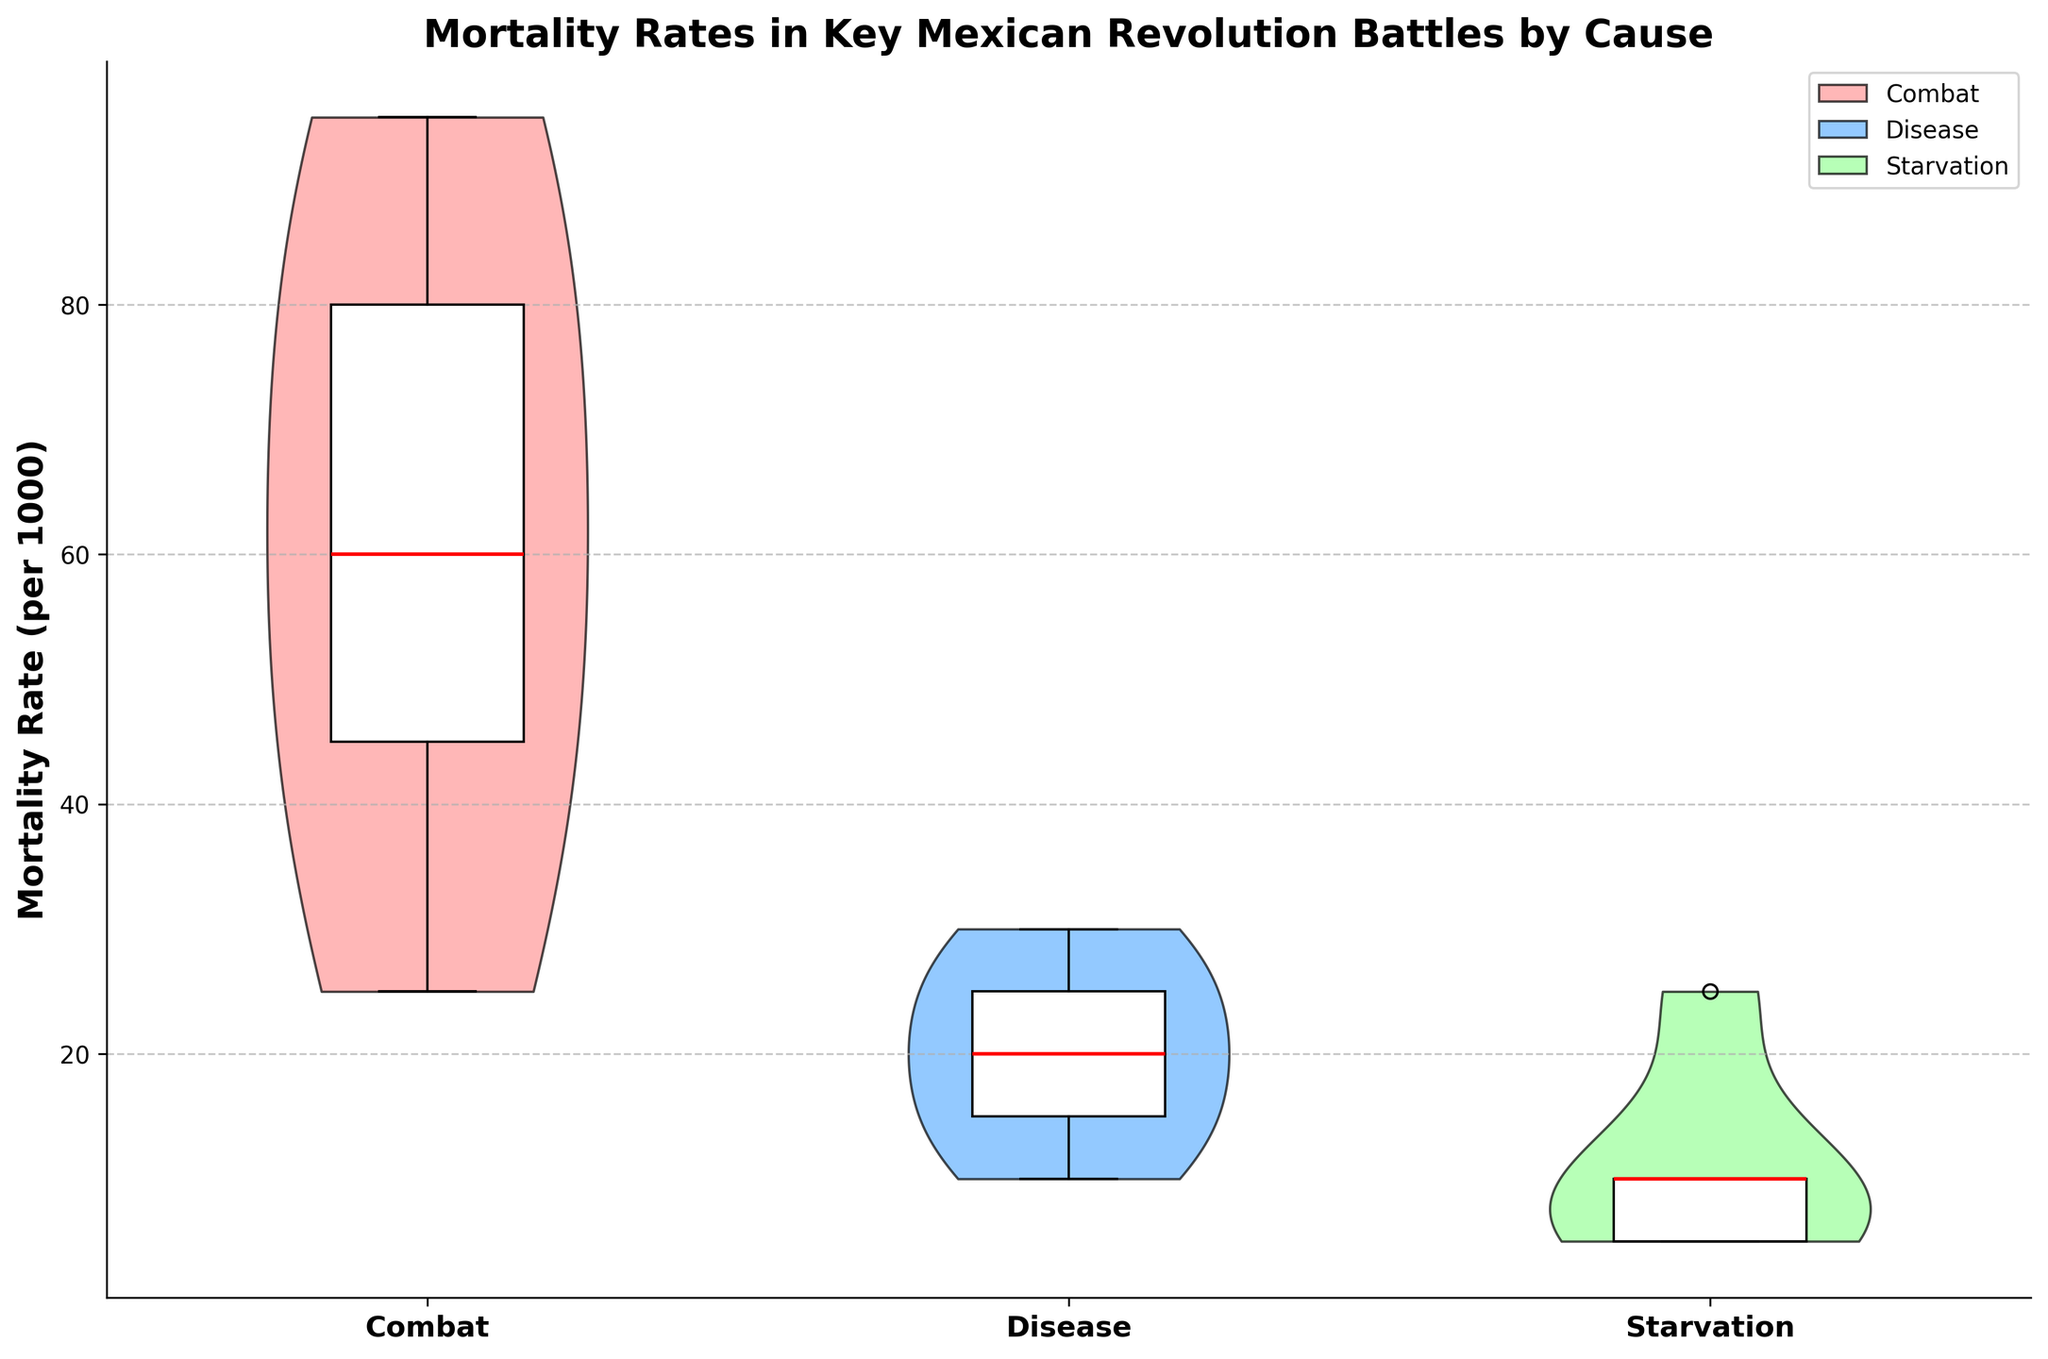What is the title of the figure? The title is located at the top of the figure and describes what the figure represents.
Answer: Mortality Rates in Key Mexican Revolution Battles by Cause What does the y-axis label indicate? The y-axis label, located along the vertical axis, describes the variable measured there.
Answer: Mortality Rate (per 1000) What causes are represented on the x-axis, and how are they visually distinguished? The x-axis indicates different causes of mortality, each represented with different colors in the violin plots and box plots. The colors included are red, blue, and green for combat, disease, and starvation respectively.
Answer: Combat, Disease, Starvation Which cause of mortality shows the highest median value in the box plot? The median value is represented by the red line within the box plot for each category. The highest median is observed in the category where the red line is highest.
Answer: Combat How does the distribution of mortality rates due to combat compare to disease? The violin plot for combat shows a wider spread of data points compared to disease, indicating greater variability. Additionally, the box plot for combat has a higher median value than disease.
Answer: Combat shows greater variability and a higher median than disease What is the interquartile range (IQR) for mortality rates due to starvation? The interquartile range (IQR) can be determined from the box plot for starvation. It's the range between the first quartile (lower edge of the box) and the third quartile (upper edge of the box). From the box plot, observe these values and compute the difference.
Answer: 10 Among the causes of mortality, which one has the least variability in mortality rates as shown in the violin plot? Variability in the violin plot can be assessed by looking at the 'spread' of the plot. Narrower spreads indicate less variability.
Answer: Starvation What is the total number of data points represented for mortality rates due to disease? Each point within the violin plot or box plot for disease will typically correspond to an individual data point. Count all such data points.
Answer: 5 Compare the median mortality rates of combat and starvation. Which one is higher, and by how much? The median is shown by the red line in the box plot. Compare the heights of the medians for combat and starvation and calculate the difference.
Answer: Combat is higher by 40 per 1000 What unique features does this figure use to convey information about the data distributions? The figure combines violin plots, which show the distribution of the data, with box plots that highlight statistical summaries like the median and quartiles.
Answer: It uses both violin plots and box plots 